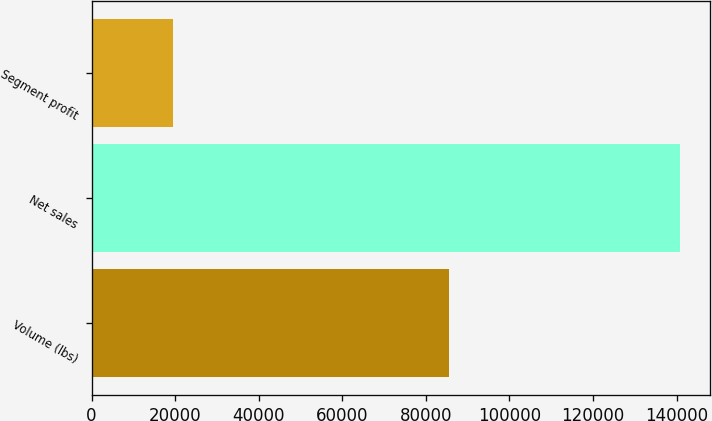<chart> <loc_0><loc_0><loc_500><loc_500><bar_chart><fcel>Volume (lbs)<fcel>Net sales<fcel>Segment profit<nl><fcel>85454<fcel>140858<fcel>19570<nl></chart> 